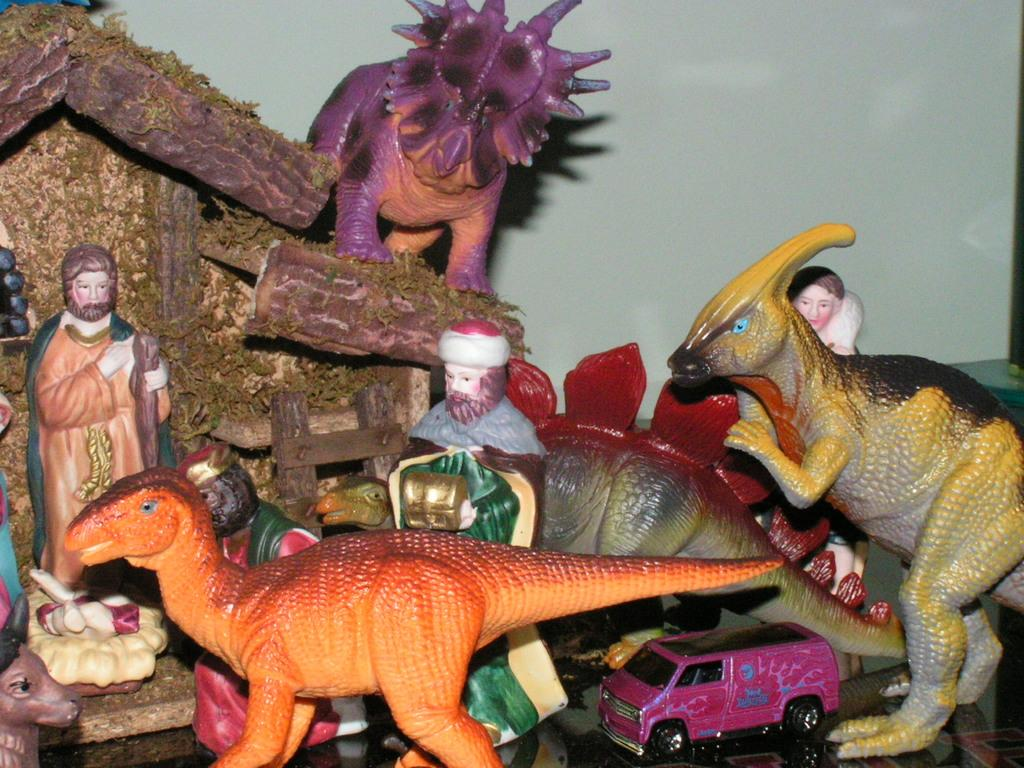What objects can be seen in the image? There are toys in the image. What type of structure is visible in the image? There is a wall in the image. How many dogs can be seen in the image? There are no dogs present in the image. What is the purpose of the toys in the image? The purpose of the toys cannot be determined from the image alone, as it depends on the context and situation. 